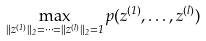<formula> <loc_0><loc_0><loc_500><loc_500>\max _ { \| z ^ { ( 1 ) } \| _ { 2 } = \cdots = \| z ^ { ( l ) } \| _ { 2 } = 1 } p ( z ^ { ( 1 ) } , \dots , z ^ { ( l ) } )</formula> 